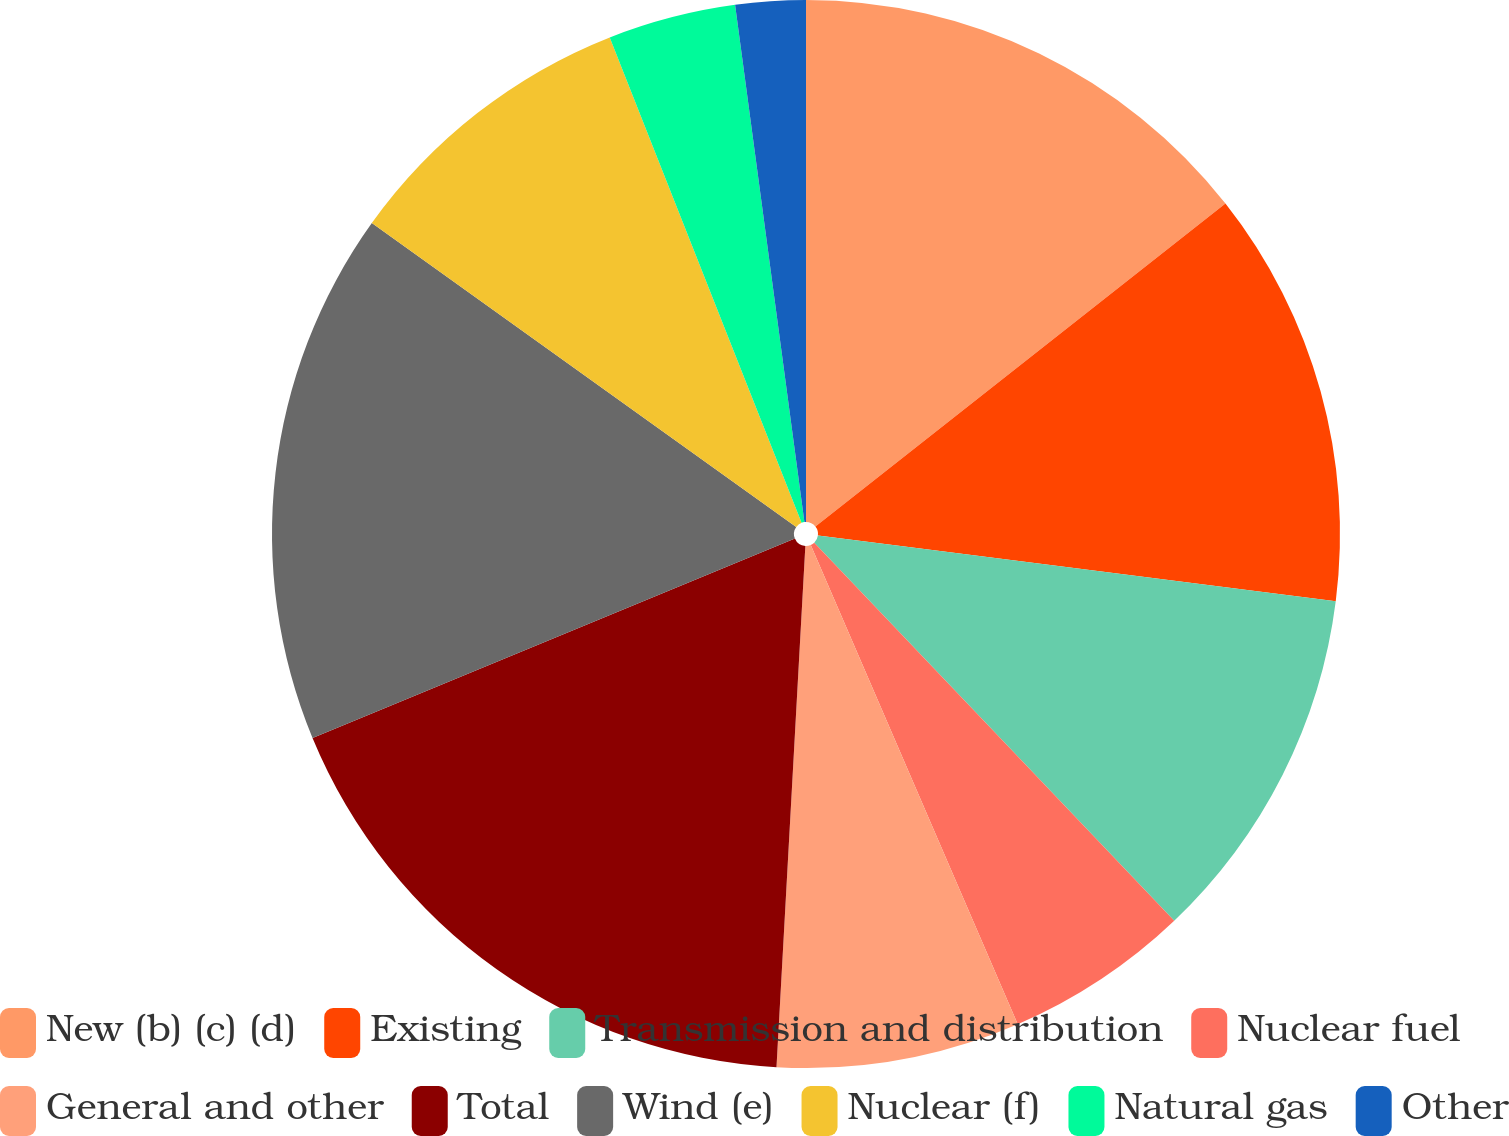Convert chart to OTSL. <chart><loc_0><loc_0><loc_500><loc_500><pie_chart><fcel>New (b) (c) (d)<fcel>Existing<fcel>Transmission and distribution<fcel>Nuclear fuel<fcel>General and other<fcel>Total<fcel>Wind (e)<fcel>Nuclear (f)<fcel>Natural gas<fcel>Other<nl><fcel>14.38%<fcel>12.63%<fcel>10.88%<fcel>5.62%<fcel>7.37%<fcel>17.88%<fcel>16.13%<fcel>9.12%<fcel>3.87%<fcel>2.12%<nl></chart> 